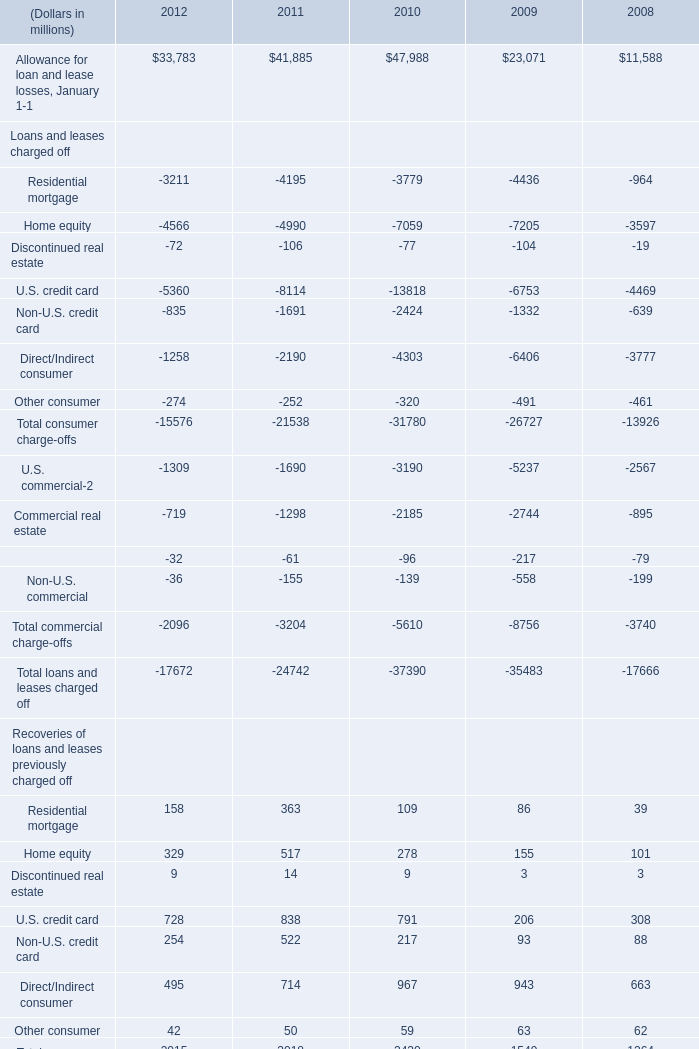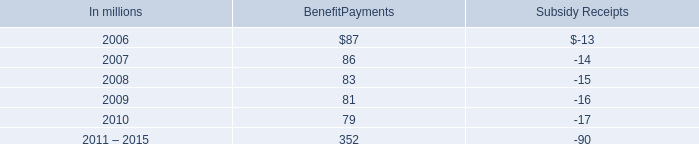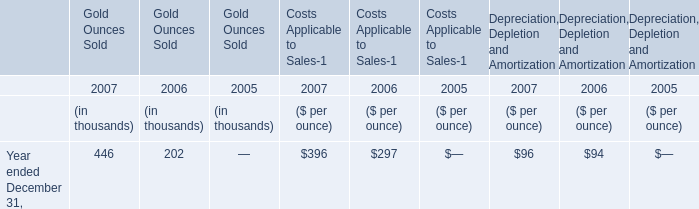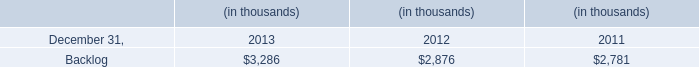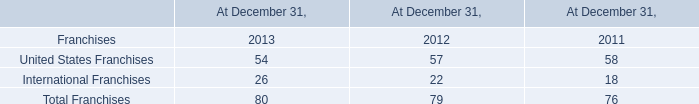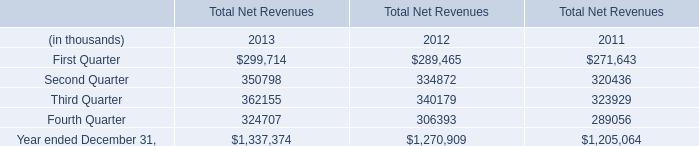What is the sum of Third Quarter in 2011 and Gold Ounces Sold in 2007? (in thousand) 
Computations: (323929 + 446)
Answer: 324375.0. 